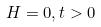Convert formula to latex. <formula><loc_0><loc_0><loc_500><loc_500>H = 0 , t > 0</formula> 